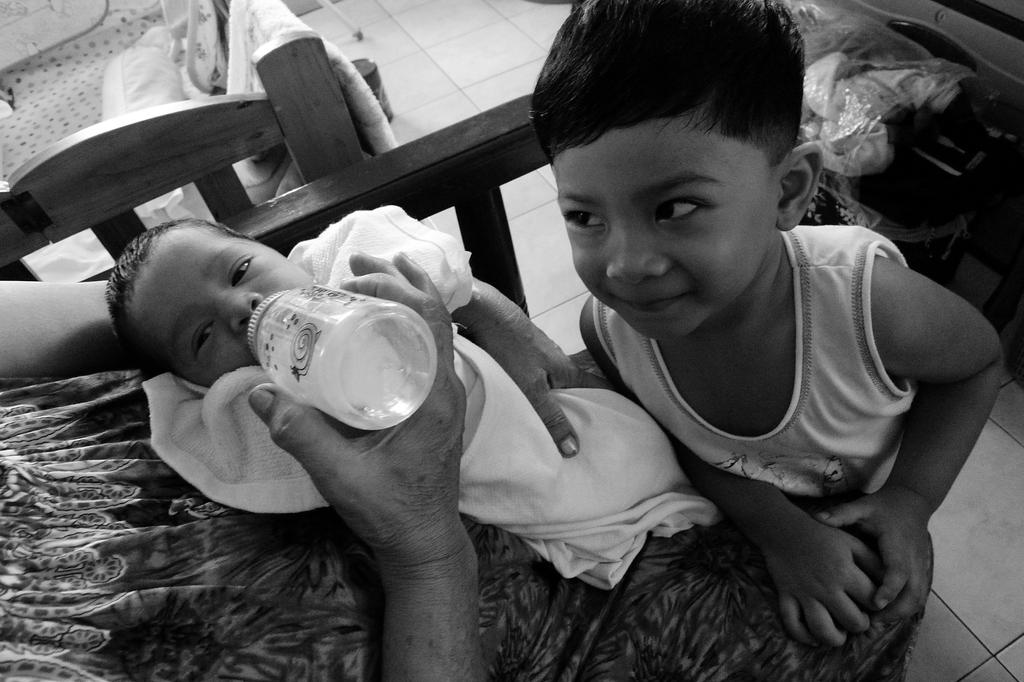What is the person holding in the image? A person's hand is holding a bottle in the image. How many children are present in the image? There are two children in the image. Can you describe the expression of one of the children? One of the children is smiling. What can be seen in the background of the image? There is a bed in the background of the image. What type of approval is the child seeking in the image? There is no indication in the image that the child is seeking approval; they are simply smiling. 